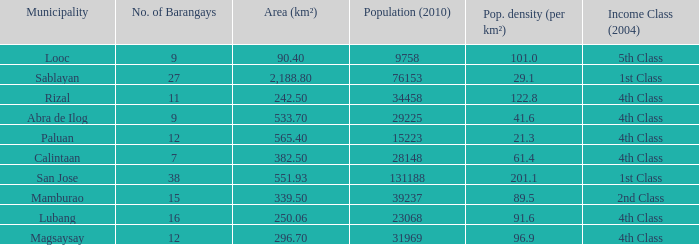List the population density per kilometer for the city of calintaan? 61.4. 